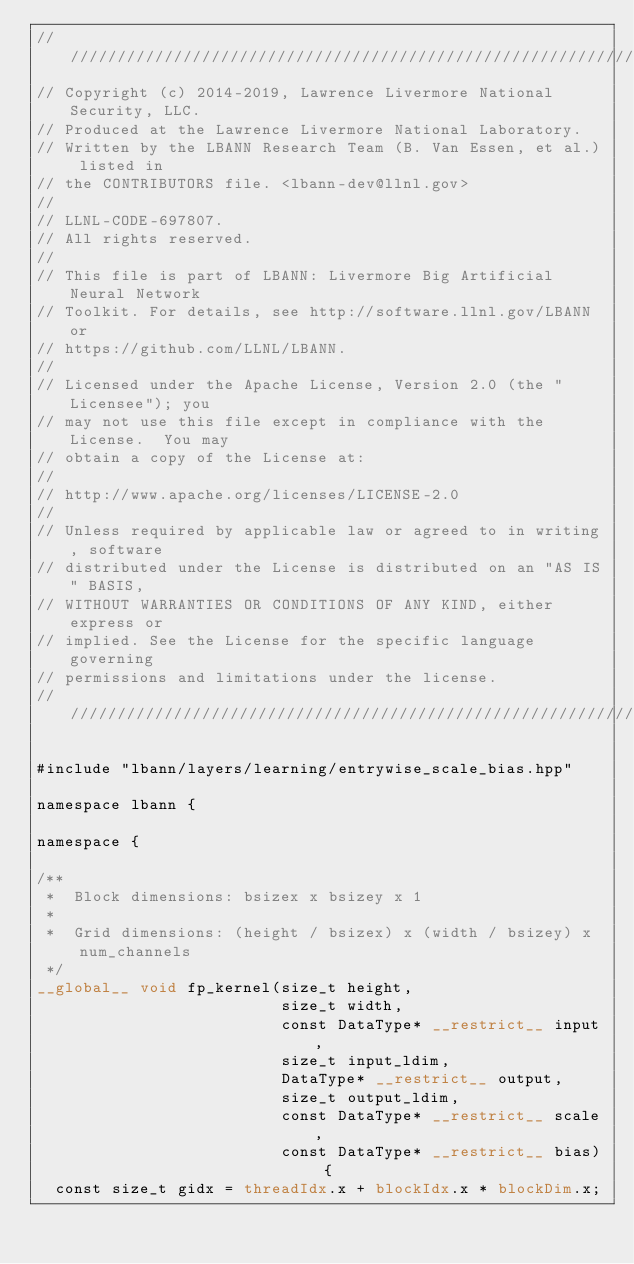<code> <loc_0><loc_0><loc_500><loc_500><_Cuda_>////////////////////////////////////////////////////////////////////////////////
// Copyright (c) 2014-2019, Lawrence Livermore National Security, LLC.
// Produced at the Lawrence Livermore National Laboratory.
// Written by the LBANN Research Team (B. Van Essen, et al.) listed in
// the CONTRIBUTORS file. <lbann-dev@llnl.gov>
//
// LLNL-CODE-697807.
// All rights reserved.
//
// This file is part of LBANN: Livermore Big Artificial Neural Network
// Toolkit. For details, see http://software.llnl.gov/LBANN or
// https://github.com/LLNL/LBANN.
//
// Licensed under the Apache License, Version 2.0 (the "Licensee"); you
// may not use this file except in compliance with the License.  You may
// obtain a copy of the License at:
//
// http://www.apache.org/licenses/LICENSE-2.0
//
// Unless required by applicable law or agreed to in writing, software
// distributed under the License is distributed on an "AS IS" BASIS,
// WITHOUT WARRANTIES OR CONDITIONS OF ANY KIND, either express or
// implied. See the License for the specific language governing
// permissions and limitations under the license.
////////////////////////////////////////////////////////////////////////////////

#include "lbann/layers/learning/entrywise_scale_bias.hpp"

namespace lbann {

namespace {

/**
 *  Block dimensions: bsizex x bsizey x 1
 *
 *  Grid dimensions: (height / bsizex) x (width / bsizey) x num_channels
 */
__global__ void fp_kernel(size_t height,
                          size_t width,
                          const DataType* __restrict__ input,
                          size_t input_ldim,
                          DataType* __restrict__ output,
                          size_t output_ldim,
                          const DataType* __restrict__ scale,
                          const DataType* __restrict__ bias) {
  const size_t gidx = threadIdx.x + blockIdx.x * blockDim.x;</code> 